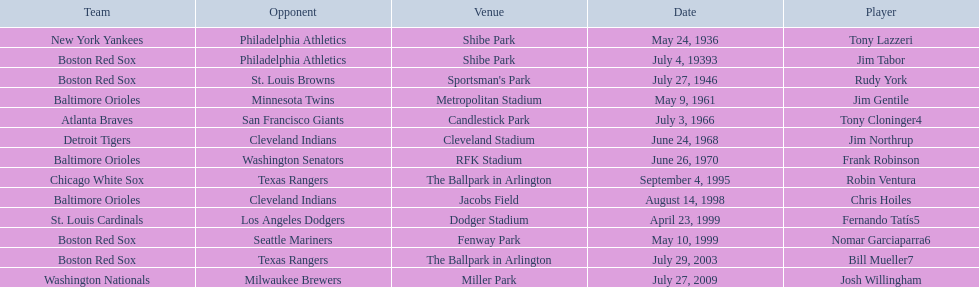What were the dates of each game? May 24, 1936, July 4, 19393, July 27, 1946, May 9, 1961, July 3, 1966, June 24, 1968, June 26, 1970, September 4, 1995, August 14, 1998, April 23, 1999, May 10, 1999, July 29, 2003, July 27, 2009. Who were all of the teams? New York Yankees, Boston Red Sox, Boston Red Sox, Baltimore Orioles, Atlanta Braves, Detroit Tigers, Baltimore Orioles, Chicago White Sox, Baltimore Orioles, St. Louis Cardinals, Boston Red Sox, Boston Red Sox, Washington Nationals. What about their opponents? Philadelphia Athletics, Philadelphia Athletics, St. Louis Browns, Minnesota Twins, San Francisco Giants, Cleveland Indians, Washington Senators, Texas Rangers, Cleveland Indians, Los Angeles Dodgers, Seattle Mariners, Texas Rangers, Milwaukee Brewers. And on which date did the detroit tigers play against the cleveland indians? June 24, 1968. 